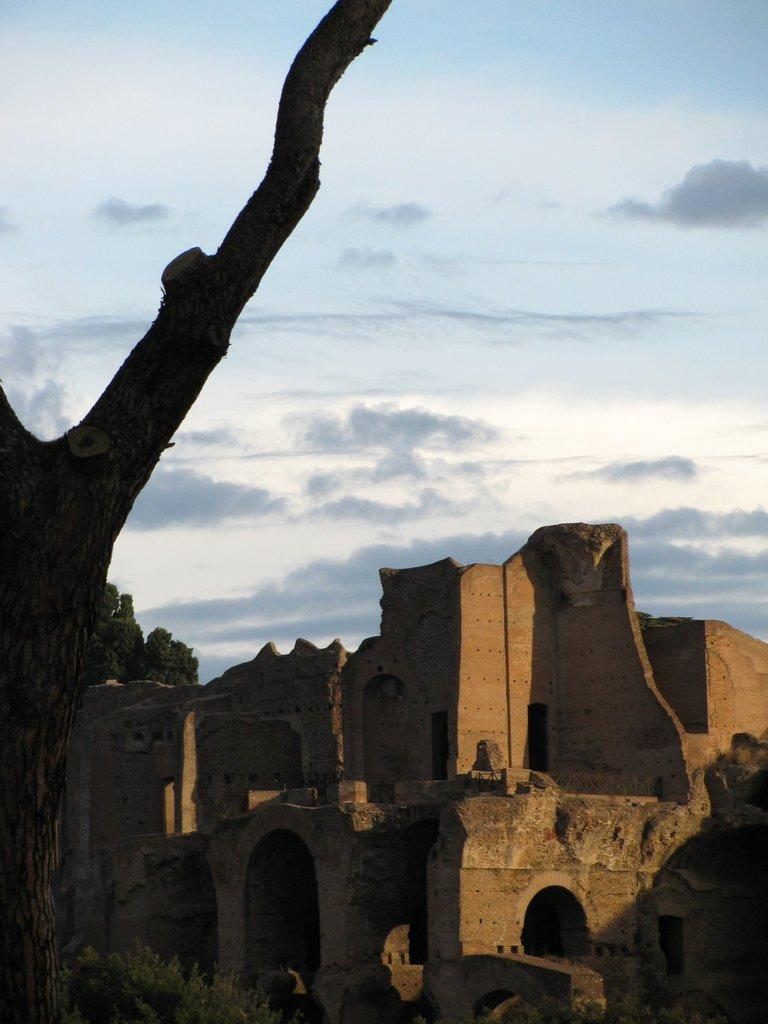What is the main structure in the center of the image? There is a fort in the center of the image. What can be seen on the left side of the image? There is a tree on the left side of the image. What is visible in the background of the image? The sky is visible in the background of the image. What else can be observed in the sky? Clouds are present in the background of the image. How many fingers can be seen pointing at the fort in the image? There are no fingers visible in the image, as it only features a fort, a tree, and the sky with clouds. 